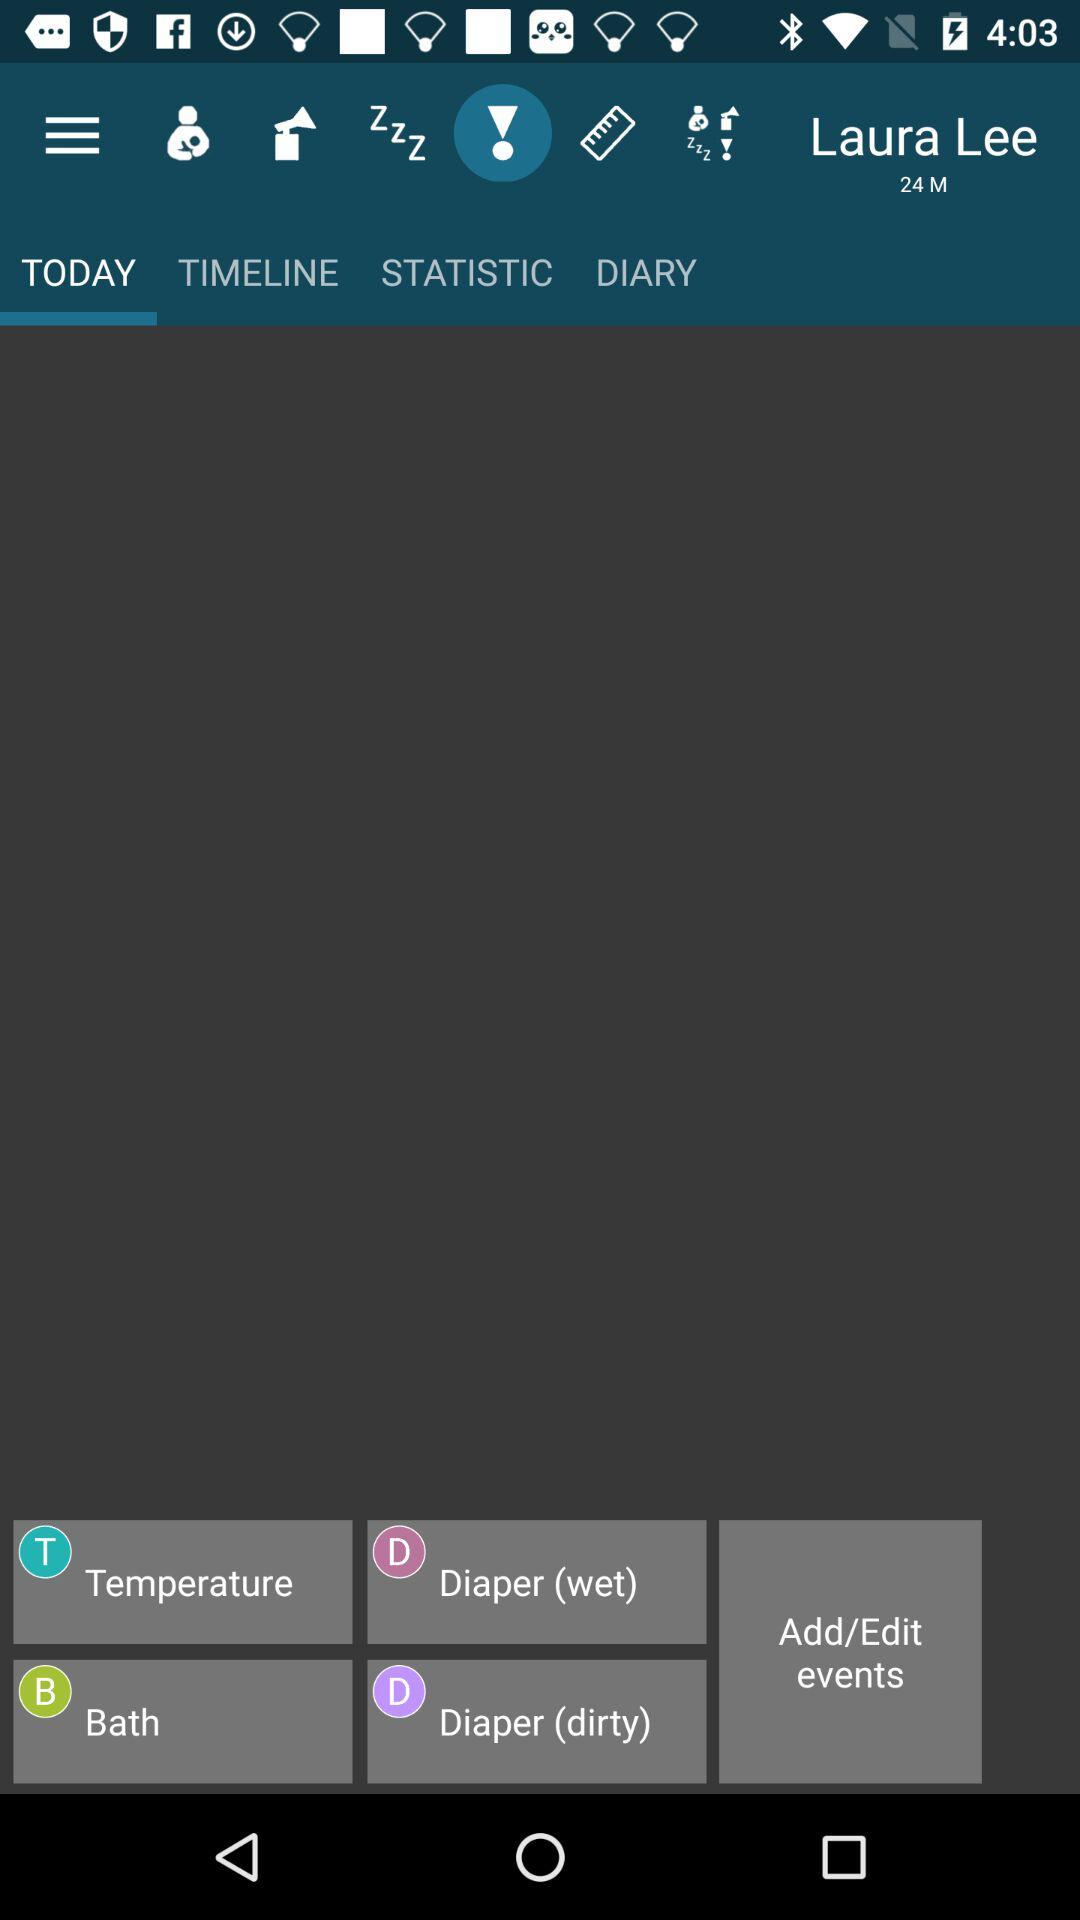How many events are there for Laura Lee?
Answer the question using a single word or phrase. 4 